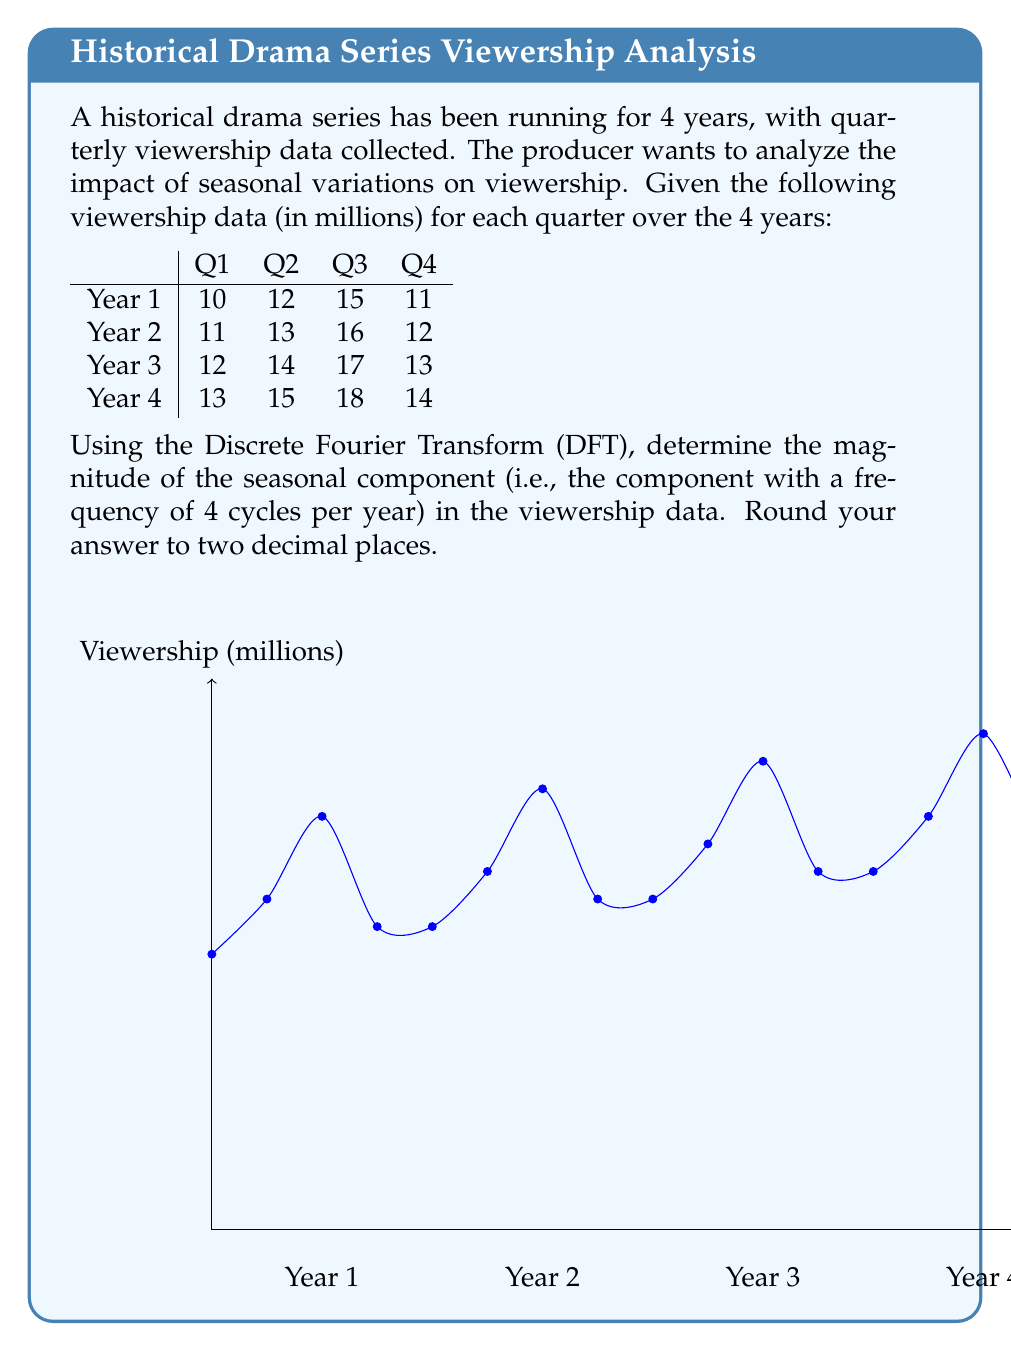Give your solution to this math problem. To solve this problem, we'll follow these steps:

1) First, we need to calculate the Discrete Fourier Transform (DFT) of the viewership data.

2) The DFT $X[k]$ of a sequence $x[n]$ of length N is given by:

   $$X[k] = \sum_{n=0}^{N-1} x[n] e^{-j2\pi kn/N}$$

   where $k = 0, 1, ..., N-1$

3) In our case, $N = 16$ (4 years * 4 quarters per year), and our sequence is:
   
   $x[n] = [10, 12, 15, 11, 11, 13, 16, 12, 12, 14, 17, 13, 13, 15, 18, 14]$

4) We're interested in the seasonal component, which has a frequency of 4 cycles per year. In the DFT, this corresponds to $k = 4$.

5) Let's calculate $X[4]$:

   $$X[4] = \sum_{n=0}^{15} x[n] e^{-j2\pi 4n/16}$$

6) Simplifying:

   $$X[4] = \sum_{n=0}^{15} x[n] e^{-j\pi n/2}$$

7) Calculating this sum (which can be done using a calculator or programming language):

   $$X[4] = -8 - 8j$$

8) The magnitude of this complex number is:

   $$|X[4]| = \sqrt{(-8)^2 + (-8)^2} = 8\sqrt{2} \approx 11.31$$

9) However, this is the magnitude for the entire 4-year period. To get the average seasonal effect per year, we need to divide by 4:

   $$\frac{|X[4]|}{4} = \frac{11.31}{4} \approx 2.83$$
Answer: 2.83 million viewers 